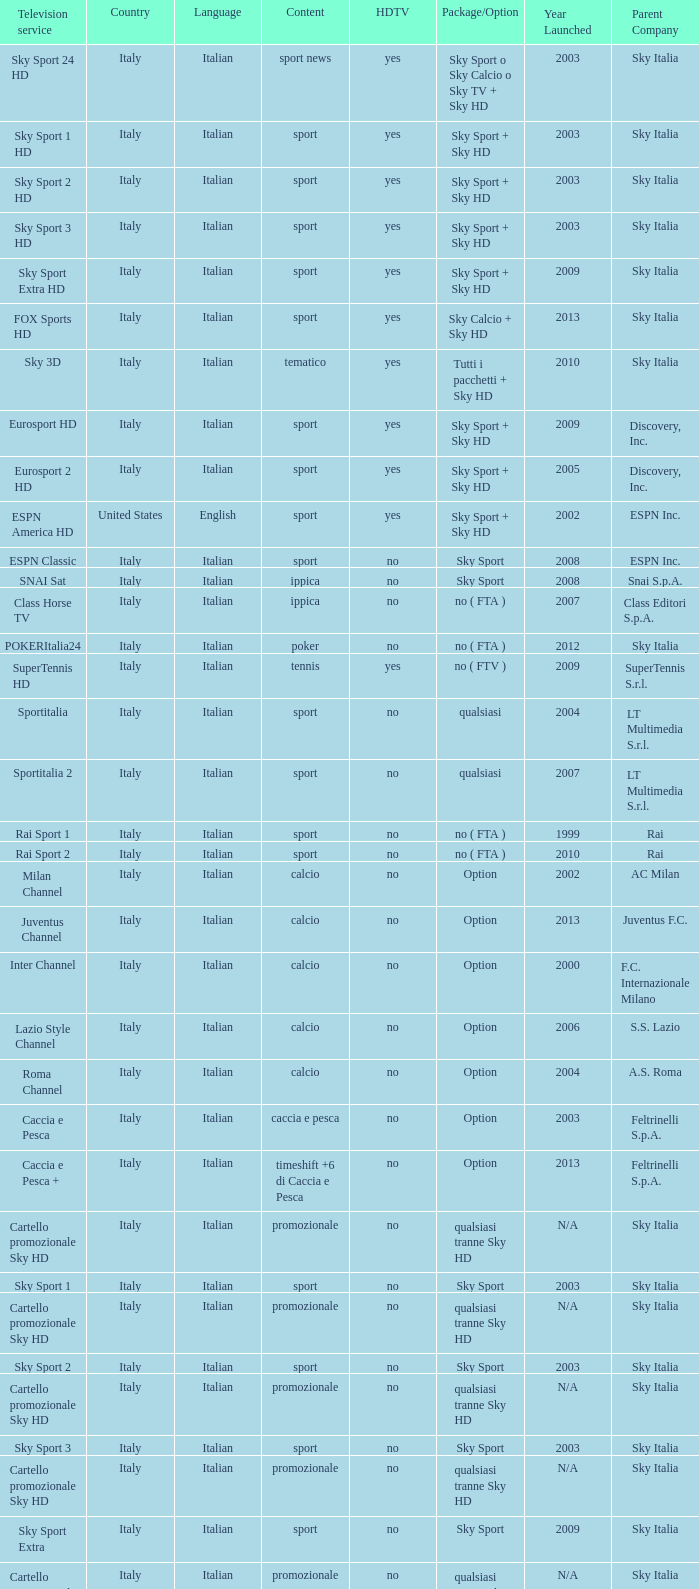What is Country, when Television Service is Eurosport 2? Italy. 